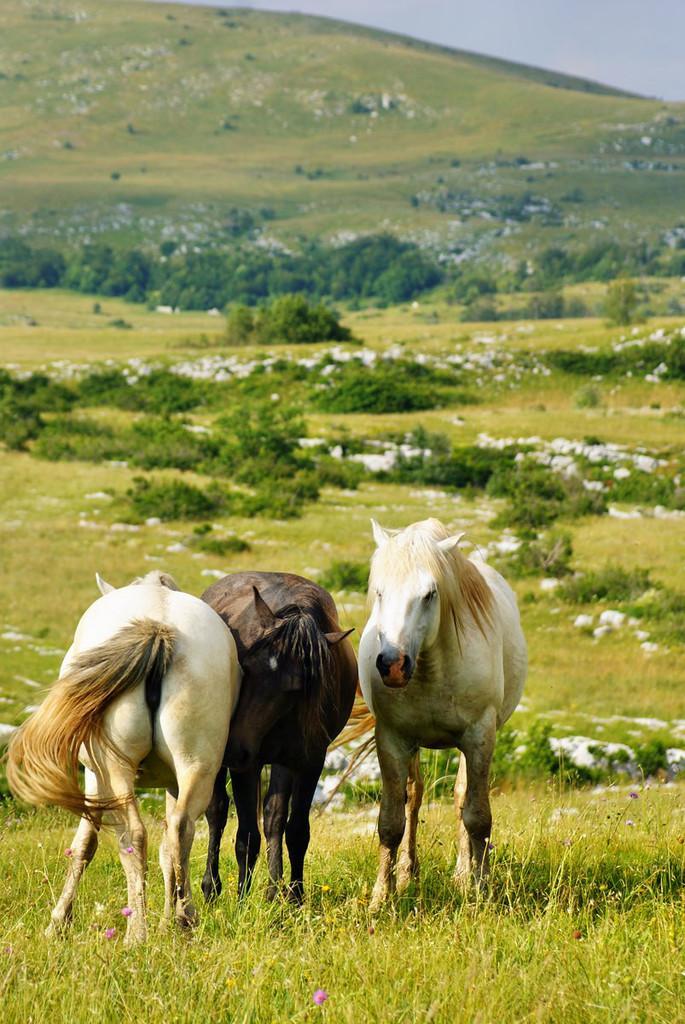What animals are present in the image? There are horses in the image. What is the ground surface like where the horses are standing? The horses are standing on green grass. What type of vegetation can be seen in the background of the image? There are green plants in the background of the image. What is visible at the top of the image? The sky is visible at the top of the image. How many geese are playing basketball with the horses in the image? There are no geese or basketballs present in the image; it features horses standing on green grass with green plants in the background and the sky visible at the top. 